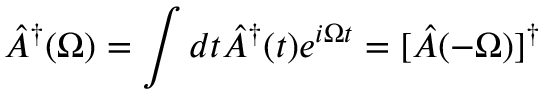Convert formula to latex. <formula><loc_0><loc_0><loc_500><loc_500>\hat { A } ^ { \dagger } ( \Omega ) = \int d t \hat { A } ^ { \dagger } ( t ) e ^ { i \Omega t } = [ \hat { A } ( - \Omega ) ] ^ { \dagger }</formula> 